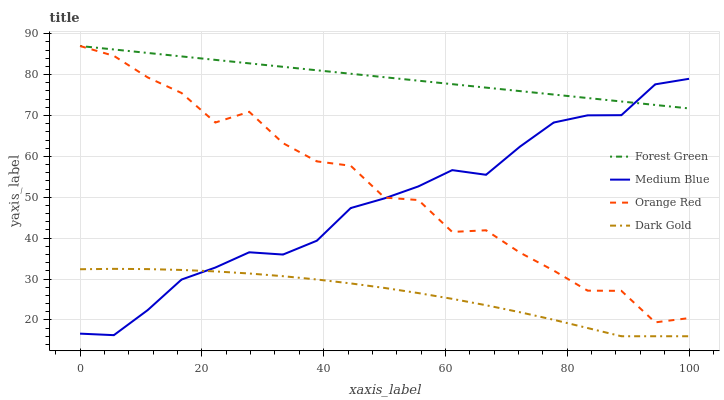Does Dark Gold have the minimum area under the curve?
Answer yes or no. Yes. Does Forest Green have the maximum area under the curve?
Answer yes or no. Yes. Does Medium Blue have the minimum area under the curve?
Answer yes or no. No. Does Medium Blue have the maximum area under the curve?
Answer yes or no. No. Is Forest Green the smoothest?
Answer yes or no. Yes. Is Orange Red the roughest?
Answer yes or no. Yes. Is Medium Blue the smoothest?
Answer yes or no. No. Is Medium Blue the roughest?
Answer yes or no. No. Does Dark Gold have the lowest value?
Answer yes or no. Yes. Does Medium Blue have the lowest value?
Answer yes or no. No. Does Orange Red have the highest value?
Answer yes or no. Yes. Does Medium Blue have the highest value?
Answer yes or no. No. Is Dark Gold less than Orange Red?
Answer yes or no. Yes. Is Forest Green greater than Dark Gold?
Answer yes or no. Yes. Does Medium Blue intersect Forest Green?
Answer yes or no. Yes. Is Medium Blue less than Forest Green?
Answer yes or no. No. Is Medium Blue greater than Forest Green?
Answer yes or no. No. Does Dark Gold intersect Orange Red?
Answer yes or no. No. 